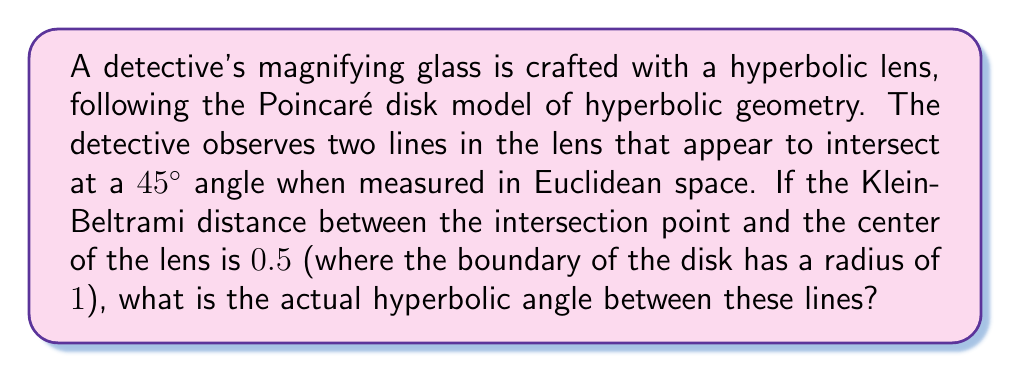Solve this math problem. Let's approach this step-by-step:

1) In the Poincaré disk model, the formula for the angle $\theta$ between two lines intersecting at a point $(r,0)$ on the x-axis is:

   $$\theta = 2 \arctan\left(\frac{\tan(\theta_E/2)}{\sqrt{1-r^2}}\right)$$

   where $\theta_E$ is the Euclidean angle and $r$ is the radial coordinate of the intersection point.

2) We're given that $\theta_E = 45°$ and the Klein-Beltrami distance is 0.5.

3) First, we need to convert the Klein-Beltrami distance to the Poincaré distance. The formula for this conversion is:

   $$r_{Poincaré} = \tanh\left(\frac{1}{2}\text{arctanh}(r_{Klein})\right)$$

4) Plugging in $r_{Klein} = 0.5$:

   $$r_{Poincaré} = \tanh\left(\frac{1}{2}\text{arctanh}(0.5)\right) \approx 0.2554$$

5) Now we can use the angle formula:

   $$\theta = 2 \arctan\left(\frac{\tan(45°/2)}{\sqrt{1-(0.2554)^2}}\right)$$

6) Simplify:
   $$\theta = 2 \arctan\left(\frac{\tan(22.5°)}{\sqrt{0.9348}}\right)$$
   $$\theta = 2 \arctan\left(\frac{0.4142}{0.9669}\right)$$
   $$\theta = 2 \arctan(0.4284)$$
   $$\theta = 2 * 0.4026 = 0.8052 \text{ radians}$$

7) Convert to degrees:
   $$\theta = 0.8052 * \frac{180°}{\pi} \approx 46.14°$$
Answer: $46.14°$ 